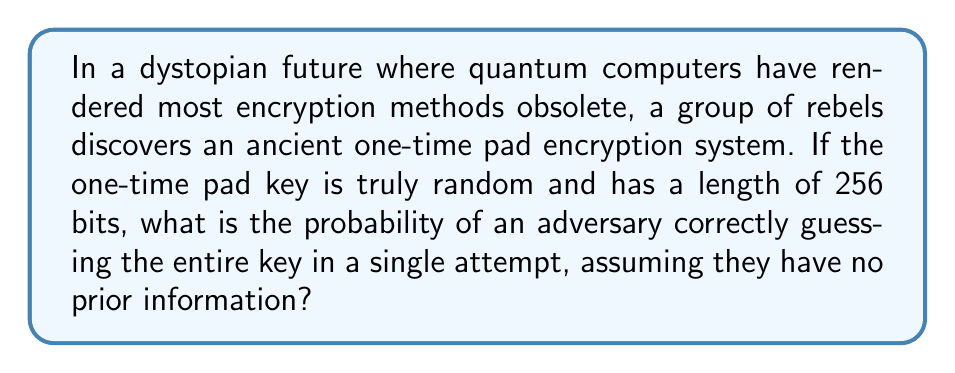Can you answer this question? To solve this problem, we need to consider the following steps:

1) A one-time pad encryption system is theoretically unbreakable if used correctly. The key must be:
   a) Truly random
   b) At least as long as the message
   c) Never reused

2) In this case, we're told the key is truly random and 256 bits long, satisfying conditions (a) and (b).

3) The probability of correctly guessing a single bit is $\frac{1}{2}$ or $0.5$, as each bit can only be 0 or 1.

4) To guess the entire key correctly, an adversary would need to guess all 256 bits correctly in sequence.

5) The probability of independent events occurring together is the product of their individual probabilities. Therefore, the probability of guessing all 256 bits correctly is:

   $$P(\text{correct guess}) = (\frac{1}{2})^{256}$$

6) We can calculate this value:

   $$(\frac{1}{2})^{256} = \frac{1}{2^{256}} \approx 8.636 \times 10^{-78}$$

This incredibly small number illustrates why one-time pads, when used correctly, are considered unbreakable. The probability of guessing the key is so low that it's effectively impossible, even with the most powerful computers imaginable.
Answer: $8.636 \times 10^{-78}$ 